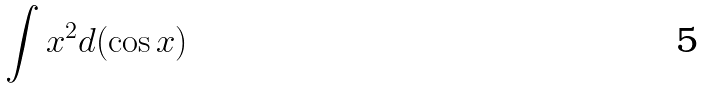Convert formula to latex. <formula><loc_0><loc_0><loc_500><loc_500>\int x ^ { 2 } d ( \cos x )</formula> 